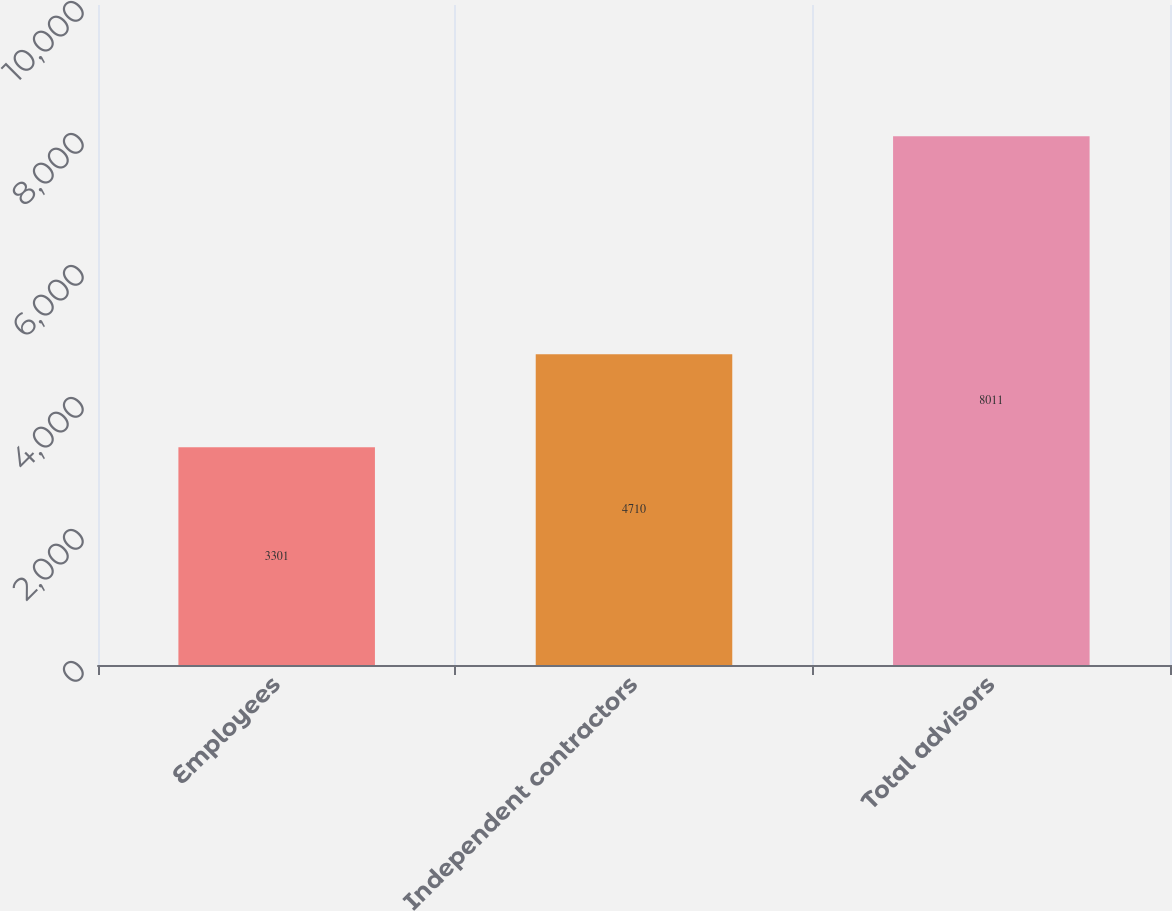Convert chart. <chart><loc_0><loc_0><loc_500><loc_500><bar_chart><fcel>Employees<fcel>Independent contractors<fcel>Total advisors<nl><fcel>3301<fcel>4710<fcel>8011<nl></chart> 